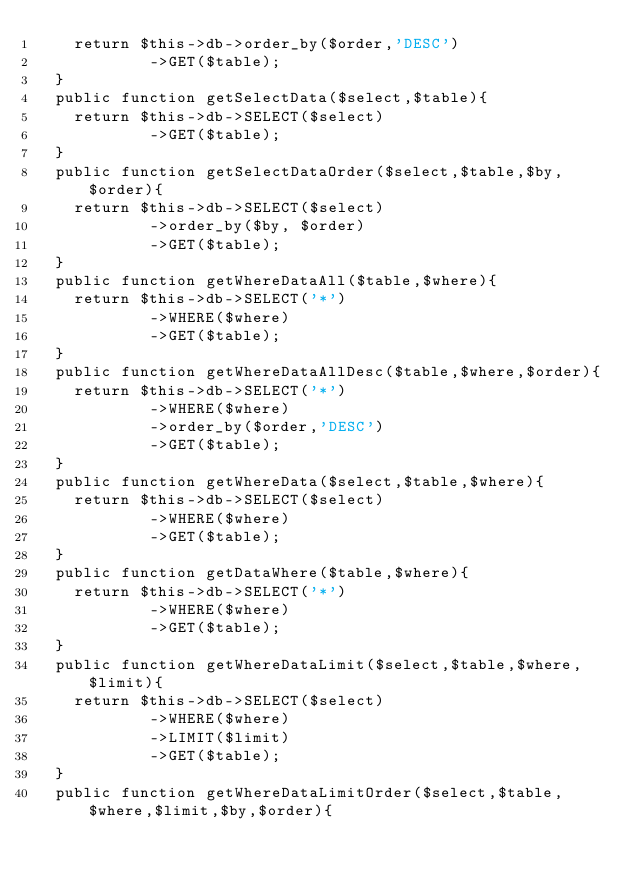<code> <loc_0><loc_0><loc_500><loc_500><_PHP_>		return $this->db->order_by($order,'DESC')
						->GET($table);
	}
	public function getSelectData($select,$table){
		return $this->db->SELECT($select)
						->GET($table);
	}
	public function getSelectDataOrder($select,$table,$by,$order){
		return $this->db->SELECT($select)
						->order_by($by, $order)
						->GET($table);
	}
	public function getWhereDataAll($table,$where){
		return $this->db->SELECT('*')
						->WHERE($where)
						->GET($table);
	}
	public function getWhereDataAllDesc($table,$where,$order){
		return $this->db->SELECT('*')
						->WHERE($where)
						->order_by($order,'DESC')
						->GET($table);
	}
	public function getWhereData($select,$table,$where){
		return $this->db->SELECT($select)
						->WHERE($where)
						->GET($table);
	}
	public function getDataWhere($table,$where){
		return $this->db->SELECT('*')
						->WHERE($where)
						->GET($table);
	}
	public function getWhereDataLimit($select,$table,$where,$limit){
		return $this->db->SELECT($select)
						->WHERE($where)
						->LIMIT($limit)
						->GET($table);
	}
	public function getWhereDataLimitOrder($select,$table,$where,$limit,$by,$order){</code> 